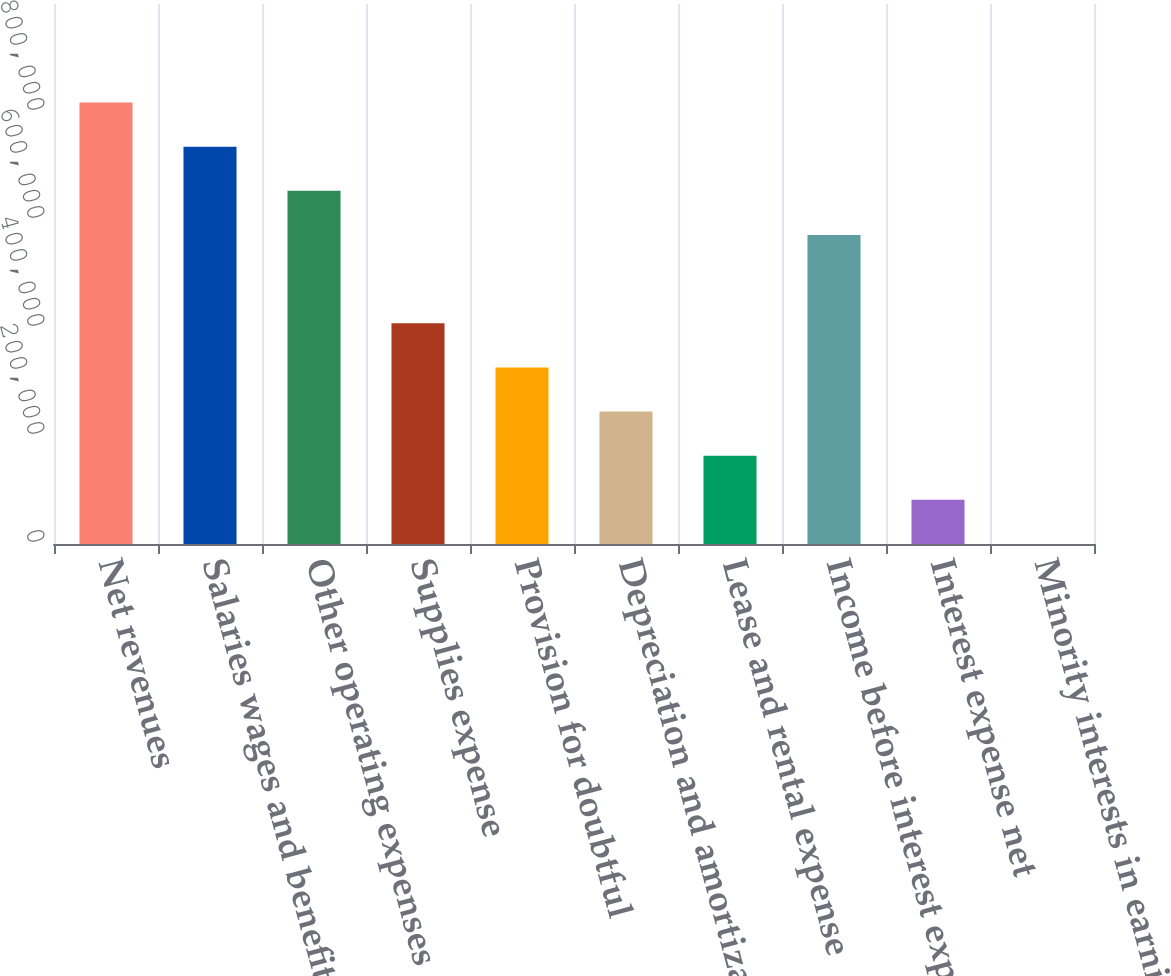Convert chart to OTSL. <chart><loc_0><loc_0><loc_500><loc_500><bar_chart><fcel>Net revenues<fcel>Salaries wages and benefits<fcel>Other operating expenses<fcel>Supplies expense<fcel>Provision for doubtful<fcel>Depreciation and amortization<fcel>Lease and rental expense<fcel>Income before interest expense<fcel>Interest expense net<fcel>Minority interests in earnings<nl><fcel>817440<fcel>735703<fcel>653966<fcel>408756<fcel>327019<fcel>245282<fcel>163546<fcel>572230<fcel>81808.8<fcel>72<nl></chart> 